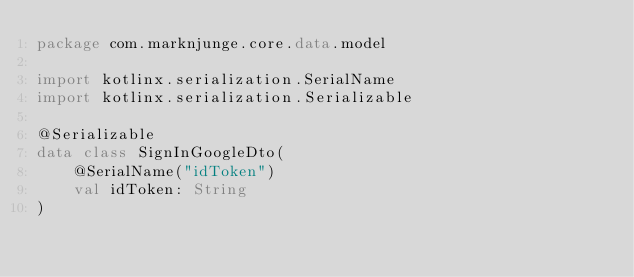Convert code to text. <code><loc_0><loc_0><loc_500><loc_500><_Kotlin_>package com.marknjunge.core.data.model

import kotlinx.serialization.SerialName
import kotlinx.serialization.Serializable

@Serializable
data class SignInGoogleDto(
    @SerialName("idToken")
    val idToken: String
)
</code> 